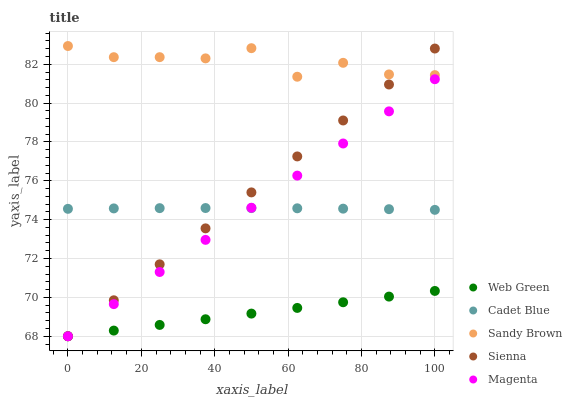Does Web Green have the minimum area under the curve?
Answer yes or no. Yes. Does Sandy Brown have the maximum area under the curve?
Answer yes or no. Yes. Does Magenta have the minimum area under the curve?
Answer yes or no. No. Does Magenta have the maximum area under the curve?
Answer yes or no. No. Is Web Green the smoothest?
Answer yes or no. Yes. Is Sandy Brown the roughest?
Answer yes or no. Yes. Is Magenta the smoothest?
Answer yes or no. No. Is Magenta the roughest?
Answer yes or no. No. Does Sienna have the lowest value?
Answer yes or no. Yes. Does Cadet Blue have the lowest value?
Answer yes or no. No. Does Sandy Brown have the highest value?
Answer yes or no. Yes. Does Magenta have the highest value?
Answer yes or no. No. Is Magenta less than Sandy Brown?
Answer yes or no. Yes. Is Sandy Brown greater than Web Green?
Answer yes or no. Yes. Does Cadet Blue intersect Magenta?
Answer yes or no. Yes. Is Cadet Blue less than Magenta?
Answer yes or no. No. Is Cadet Blue greater than Magenta?
Answer yes or no. No. Does Magenta intersect Sandy Brown?
Answer yes or no. No. 